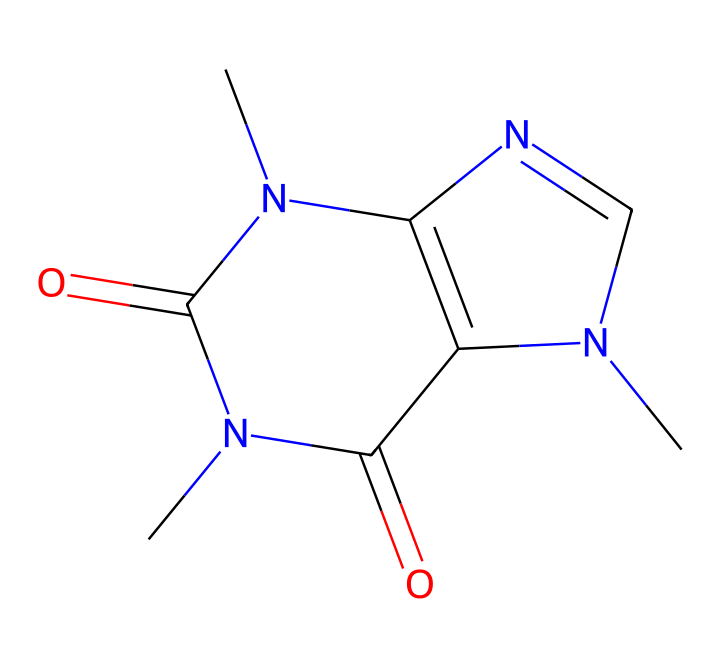What is the name of this chemical? The SMILES representation corresponds to a specific molecular structure that can be identified as caffeine, a common stimulant found in energy drinks.
Answer: caffeine How many nitrogen atoms are in this structure? By examining the SMILES representation and counting the nitrogen (N) symbols present, there are four nitrogen atoms in the molecular structure of caffeine.
Answer: four What type of bonds are primarily present in this molecule? The structure reveals a combination of single and double bonds, specific to the connections between carbon (C), nitrogen (N), and oxygen (O) atoms seen in caffeine, leading to a predominance of covalent bonds.
Answer: covalent How many rings are present in the structure? The visual representation based on the SMILES indicates two fused rings known as a bicyclic structure, essential to caffeine’s molecular identity.
Answer: two Which functional groups are part of this compound? The structure contains two carbonyl groups (C=O) and an amine group (NH), demonstrating the presence of functional groups that define its chemical characteristics.
Answer: carbonyl and amine What is the molecular formula of caffeine? By analyzing the counts of each atom in the SMILES, the molecular formula derived is C8H10N4O2, which summarizes the composition of caffeine.
Answer: C8H10N4O2 What unique properties make caffeine a stimulant? The presence of nitrogen atoms and the specific molecular arrangement contribute to caffeine interacting with neurotransmitter receptors in the brain, leading to its stimulant effects.
Answer: interacts with receptors 